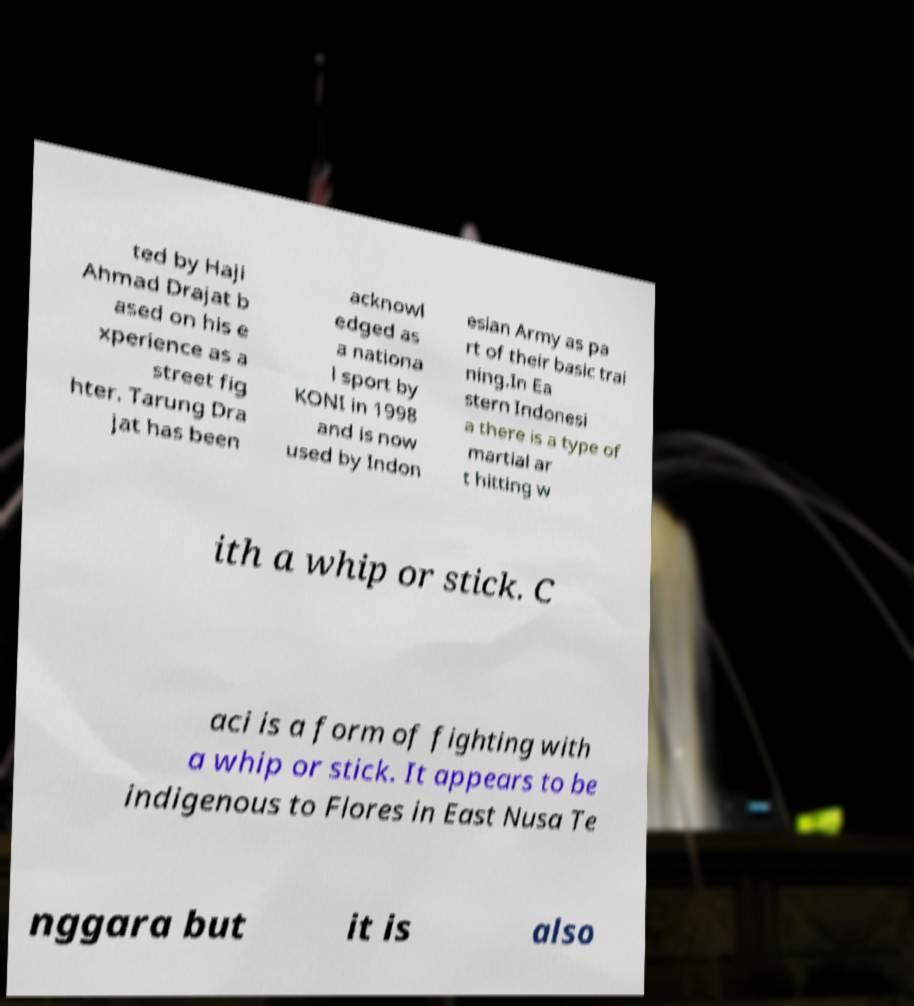What messages or text are displayed in this image? I need them in a readable, typed format. ted by Haji Ahmad Drajat b ased on his e xperience as a street fig hter. Tarung Dra jat has been acknowl edged as a nationa l sport by KONI in 1998 and is now used by Indon esian Army as pa rt of their basic trai ning.In Ea stern Indonesi a there is a type of martial ar t hitting w ith a whip or stick. C aci is a form of fighting with a whip or stick. It appears to be indigenous to Flores in East Nusa Te nggara but it is also 